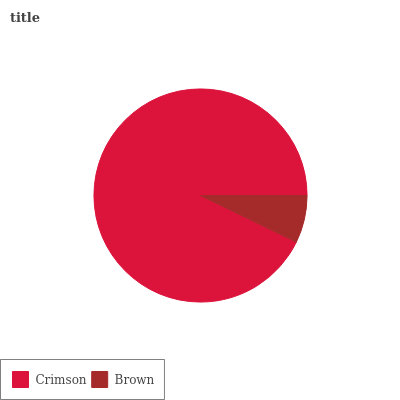Is Brown the minimum?
Answer yes or no. Yes. Is Crimson the maximum?
Answer yes or no. Yes. Is Brown the maximum?
Answer yes or no. No. Is Crimson greater than Brown?
Answer yes or no. Yes. Is Brown less than Crimson?
Answer yes or no. Yes. Is Brown greater than Crimson?
Answer yes or no. No. Is Crimson less than Brown?
Answer yes or no. No. Is Crimson the high median?
Answer yes or no. Yes. Is Brown the low median?
Answer yes or no. Yes. Is Brown the high median?
Answer yes or no. No. Is Crimson the low median?
Answer yes or no. No. 